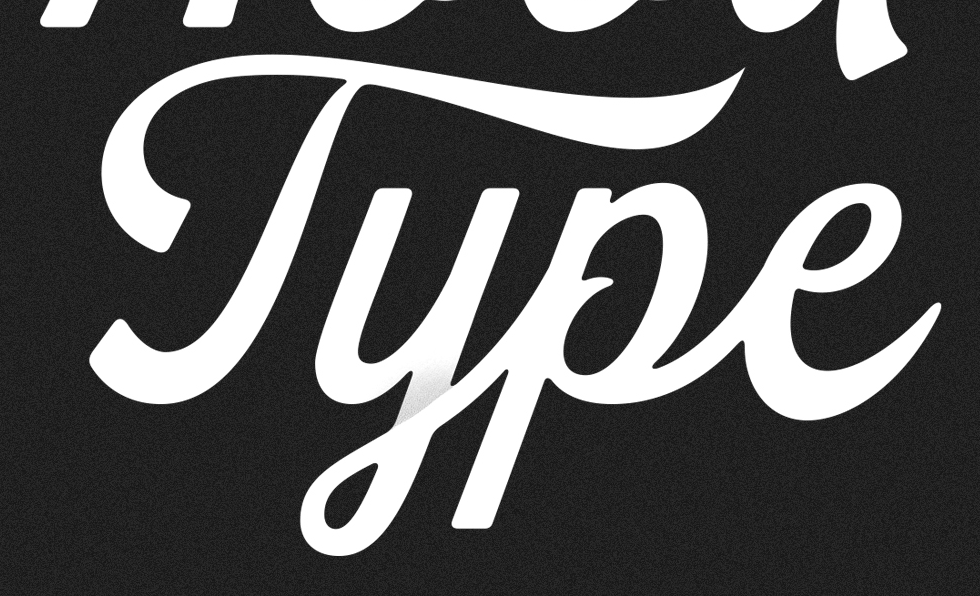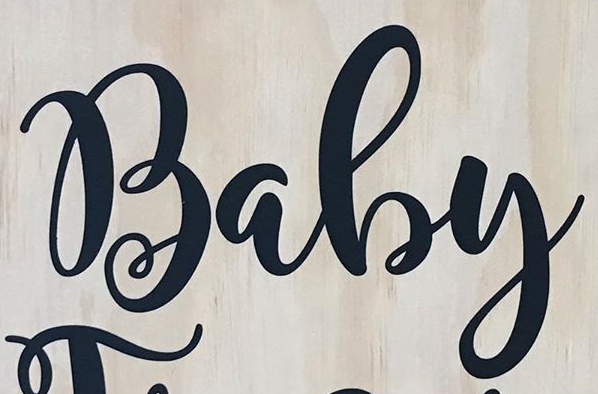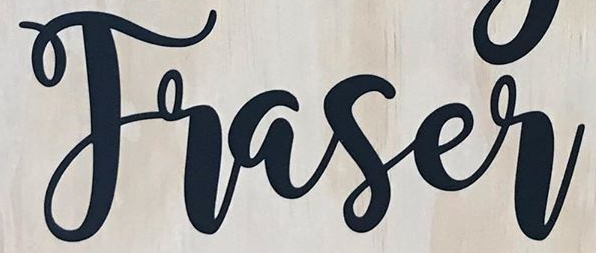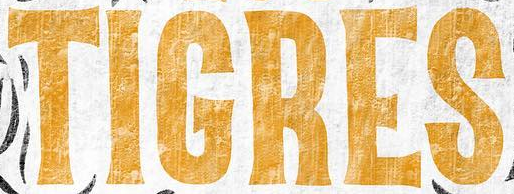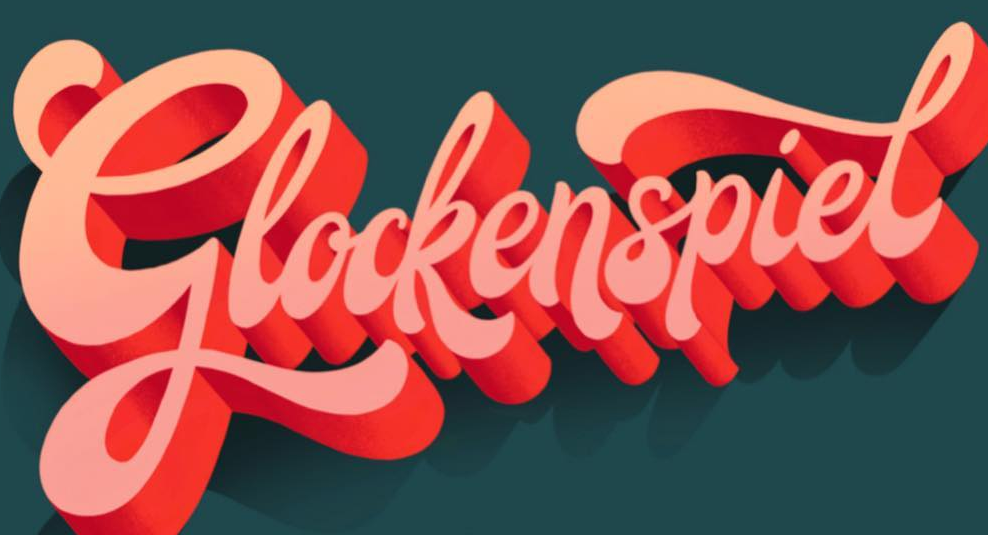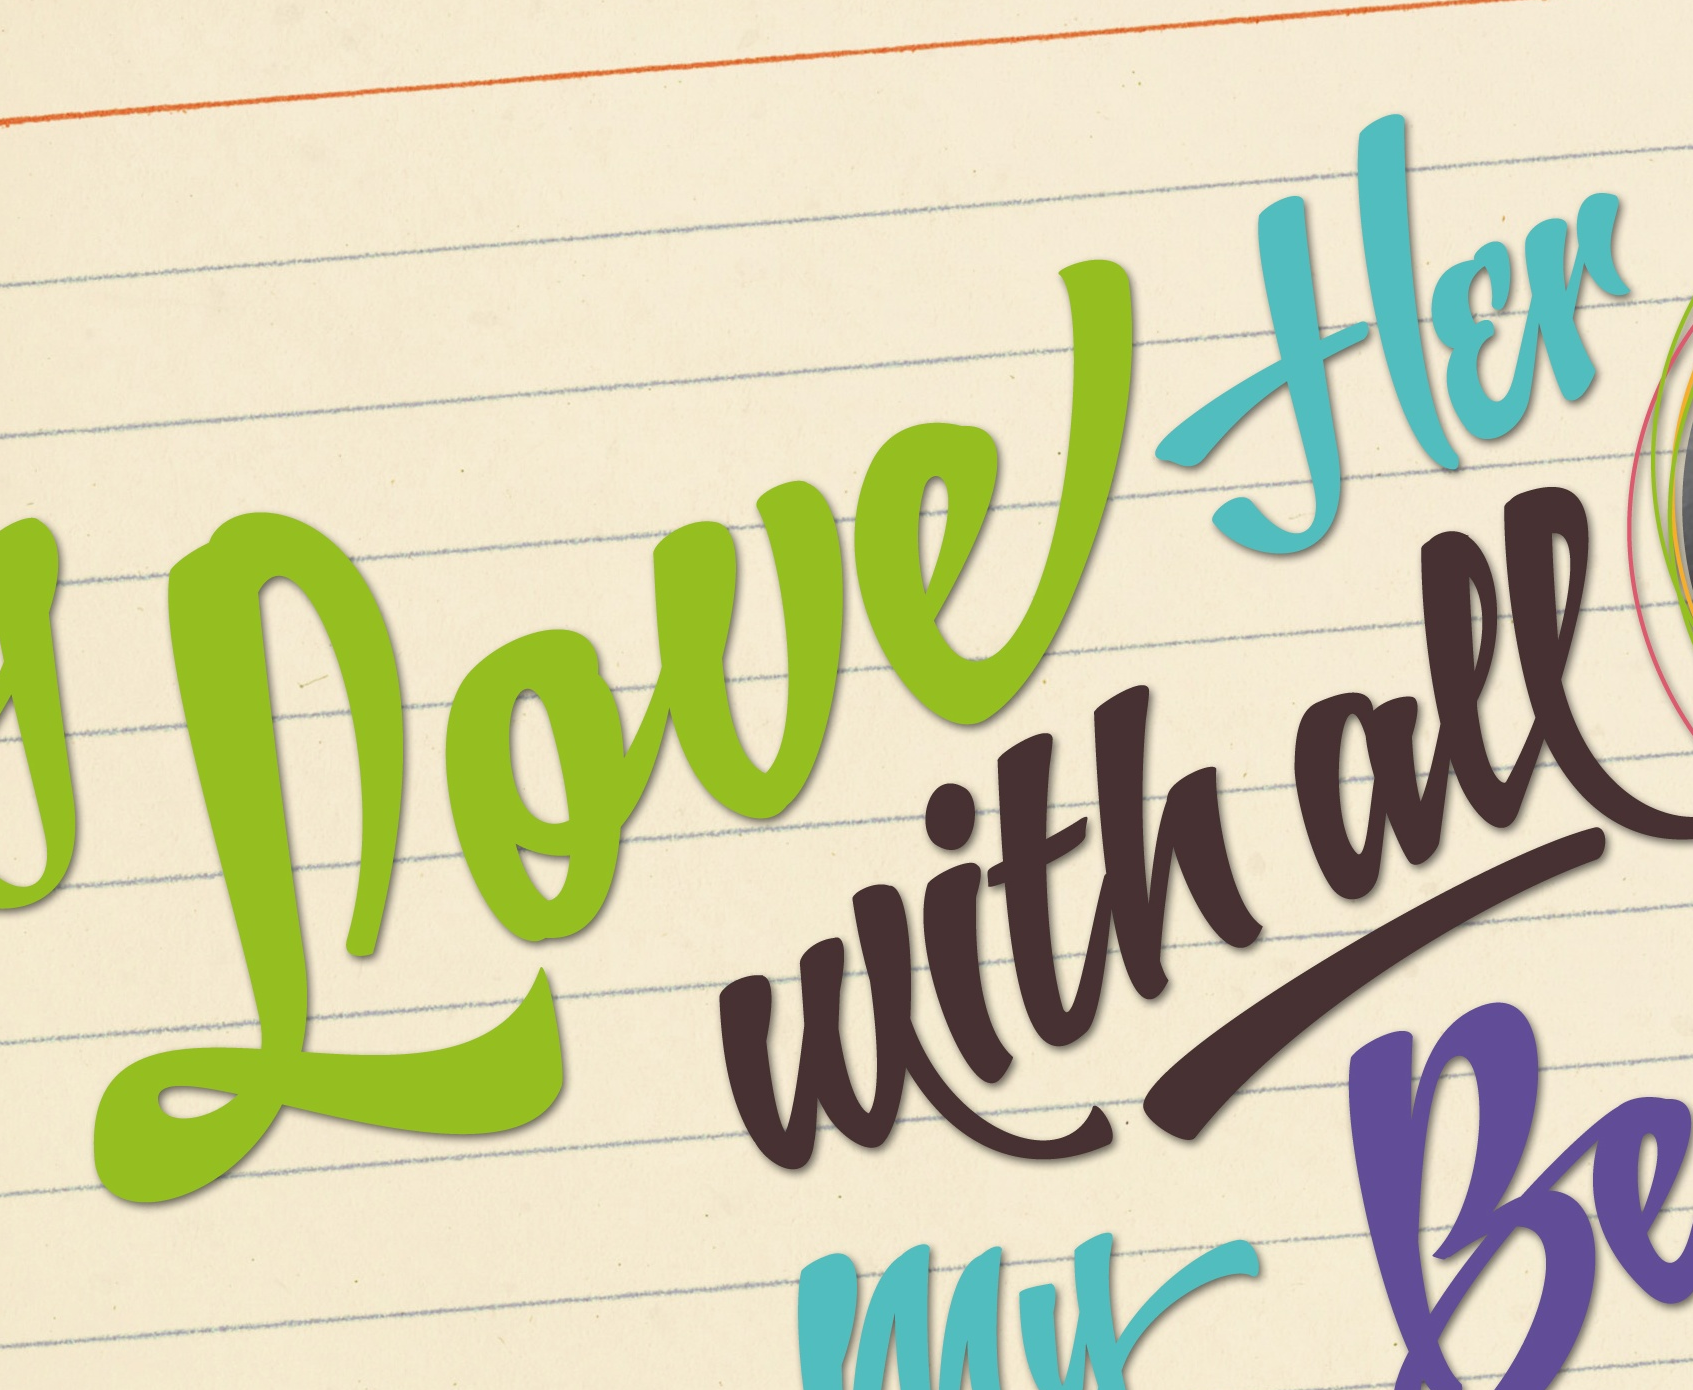Transcribe the words shown in these images in order, separated by a semicolon. Type; Baby; Traser; TIGRES; Glockenspiel; Loueflɛr 